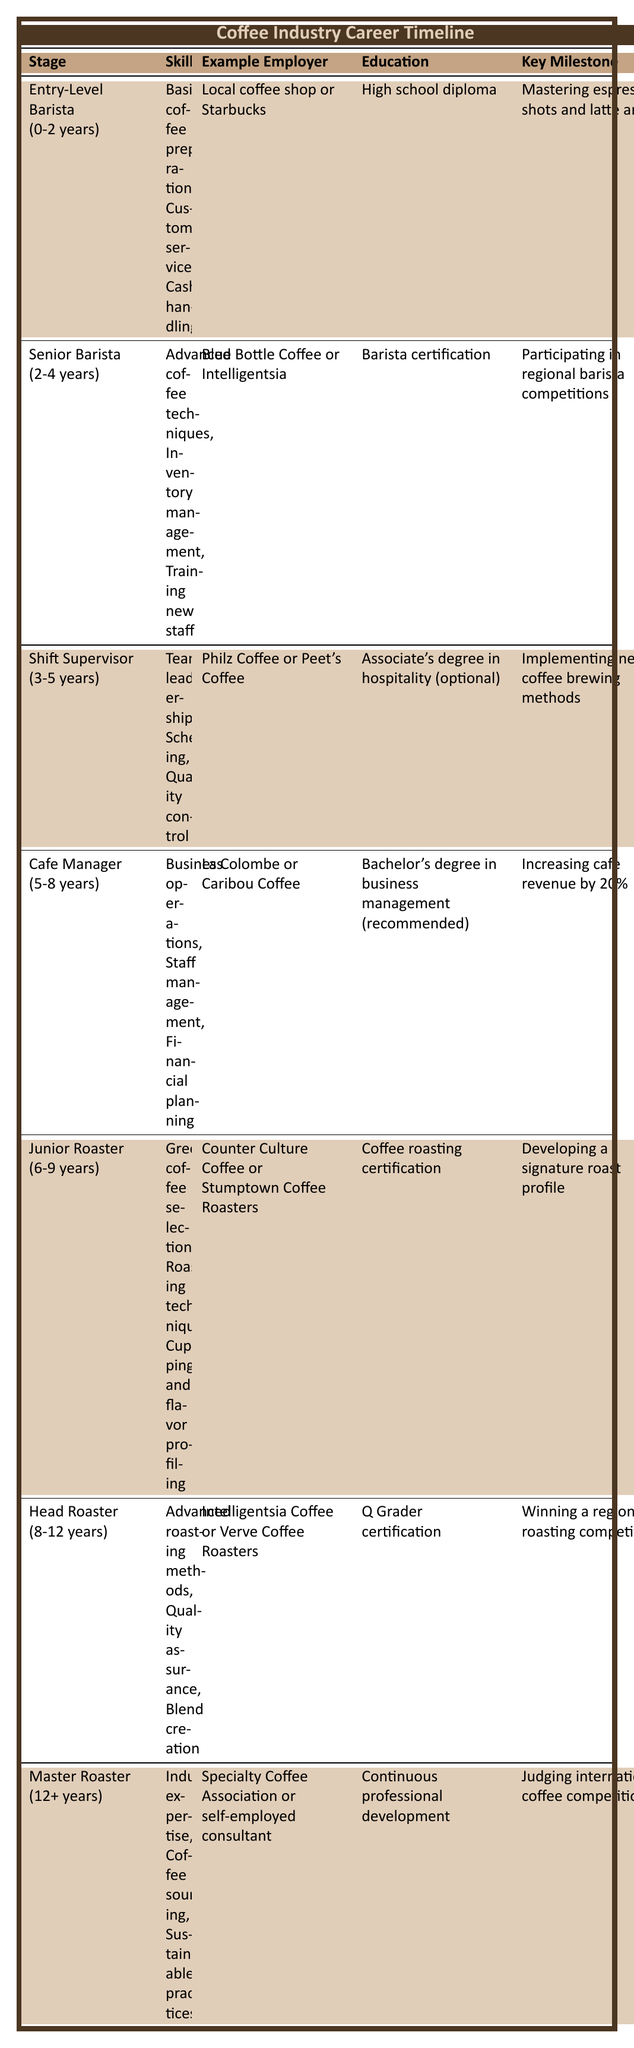What is the key milestone for a Senior Barista? The table shows that the key milestone for a Senior Barista is participating in regional barista competitions.
Answer: Participating in regional barista competitions What skills are required for the Head Roaster position? According to the table, the skills required for a Head Roaster include advanced roasting methods, quality assurance, and blend creation.
Answer: Advanced roasting methods, quality assurance, blend creation Which stage has the longest duration? By examining the duration of each stage, the Master Roaster position has a duration of 12+ years, making it the longest stage.
Answer: Master Roaster Is a high school diploma sufficient for becoming a Cafe Manager? The table indicates that a bachelor's degree in business management is recommended for a Cafe Manager, suggesting that a high school diploma alone is not sufficient.
Answer: No How many years of experience do you need to qualify as a Junior Roaster? The table states that a Junior Roaster typically requires 6-9 years of experience. Thus, the minimum requirement is 6 years.
Answer: 6 years What is the average duration of the barista stages (Entry-Level Barista, Senior Barista, and Shift Supervisor)? The durations for these stages are 2 years (Entry-Level Barista), 2 years (Senior Barista), and 2 years (Shift Supervisor), yielding an average of (0-2 + 2-4 + 3-5)/3 = (2 + 3 + 4)/3 = 3 years.
Answer: 3 years Does the Junior Roaster require a certification, and if so, which one? The table specifies that a Junior Roaster needs a coffee roasting certification to qualify for the position.
Answer: Yes, coffee roasting certification What key milestone is associated with the Cafe Manager role? According to the table, the key milestone for a Cafe Manager is increasing cafe revenue by 20%.
Answer: Increasing cafe revenue by 20% Which example employer is listed for the Master Roaster stage? The table specifies that either the Specialty Coffee Association or a self-employed consultant serves as an example employer for the Master Roaster.
Answer: Specialty Coffee Association or self-employed consultant How many total years of experience are required from Entry-Level Barista to Master Roaster? The timeline indicates that an Entry-Level Barista has a duration of 0-2 years, while the Master Roaster requires 12+ years, totaling a minimum of 12 years of experience required, if we consider the overlapping experience in roles.
Answer: 12 years 